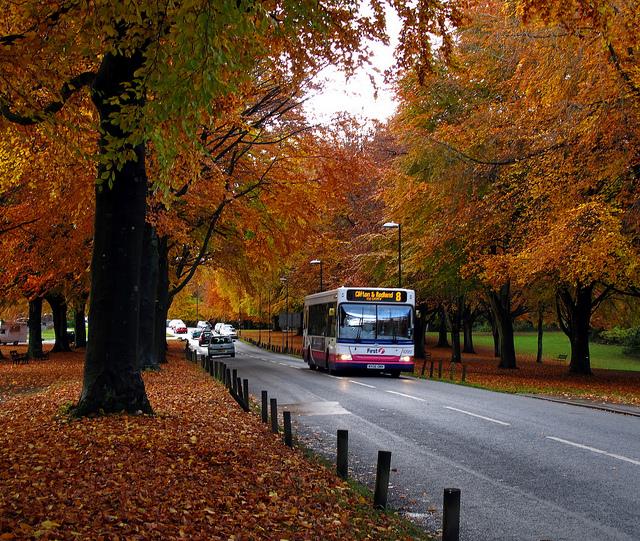Are the white arrows painted on the pavement?
Be succinct. No. What vacation spot is this taken at?
Answer briefly. New england. What has headlights?
Keep it brief. Bus. What color is most of the tree leaves?
Short answer required. Orange. What's the color of the babies sleeper?
Keep it brief. Blue. Is this road safe to drive on?
Be succinct. Yes. How many buses are there?
Quick response, please. 1. What season is this?
Concise answer only. Fall. 